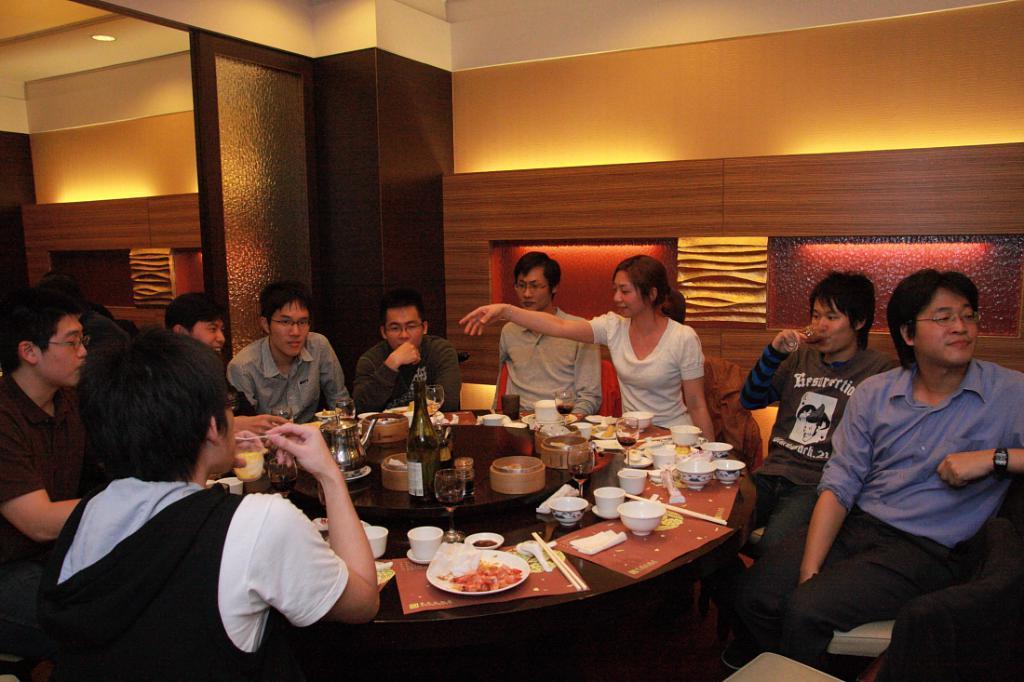Could you give a brief overview of what you see in this image? in the image we can see group of people were sitting on the chair around the table. On table we can see some food items. And some more objects like plate,cup,wine glass ,bottle etc. And back we can see the wall. 